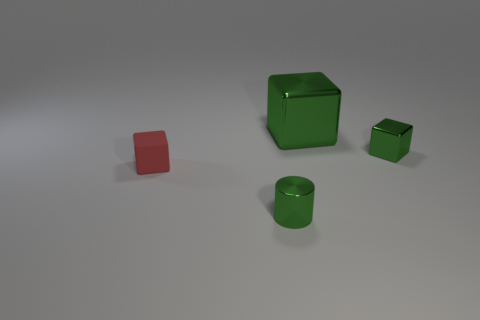Is the number of rubber cubes on the left side of the red block less than the number of shiny things in front of the big green thing?
Give a very brief answer. Yes. What number of other objects are the same material as the cylinder?
Your response must be concise. 2. There is a big metal thing that is on the right side of the tiny red thing; is it the same color as the cylinder?
Offer a terse response. Yes. Is there a metallic cylinder behind the object that is left of the metal cylinder?
Your answer should be very brief. No. What material is the cube that is to the right of the tiny rubber object and in front of the large block?
Your answer should be very brief. Metal. The big green object that is made of the same material as the small cylinder is what shape?
Offer a very short reply. Cube. Is there anything else that is the same shape as the tiny red rubber object?
Offer a very short reply. Yes. Does the green block that is to the left of the small metal cube have the same material as the red block?
Keep it short and to the point. No. What material is the small cube right of the big block?
Your answer should be compact. Metal. There is a block to the left of the tiny metallic object in front of the red matte block; what size is it?
Make the answer very short. Small. 